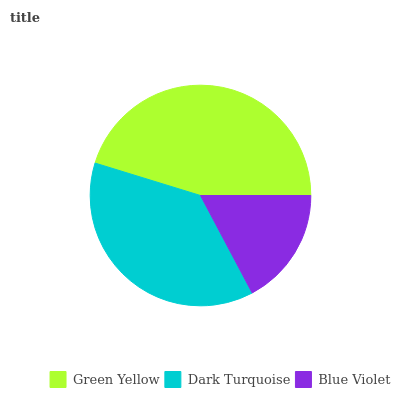Is Blue Violet the minimum?
Answer yes or no. Yes. Is Green Yellow the maximum?
Answer yes or no. Yes. Is Dark Turquoise the minimum?
Answer yes or no. No. Is Dark Turquoise the maximum?
Answer yes or no. No. Is Green Yellow greater than Dark Turquoise?
Answer yes or no. Yes. Is Dark Turquoise less than Green Yellow?
Answer yes or no. Yes. Is Dark Turquoise greater than Green Yellow?
Answer yes or no. No. Is Green Yellow less than Dark Turquoise?
Answer yes or no. No. Is Dark Turquoise the high median?
Answer yes or no. Yes. Is Dark Turquoise the low median?
Answer yes or no. Yes. Is Green Yellow the high median?
Answer yes or no. No. Is Green Yellow the low median?
Answer yes or no. No. 